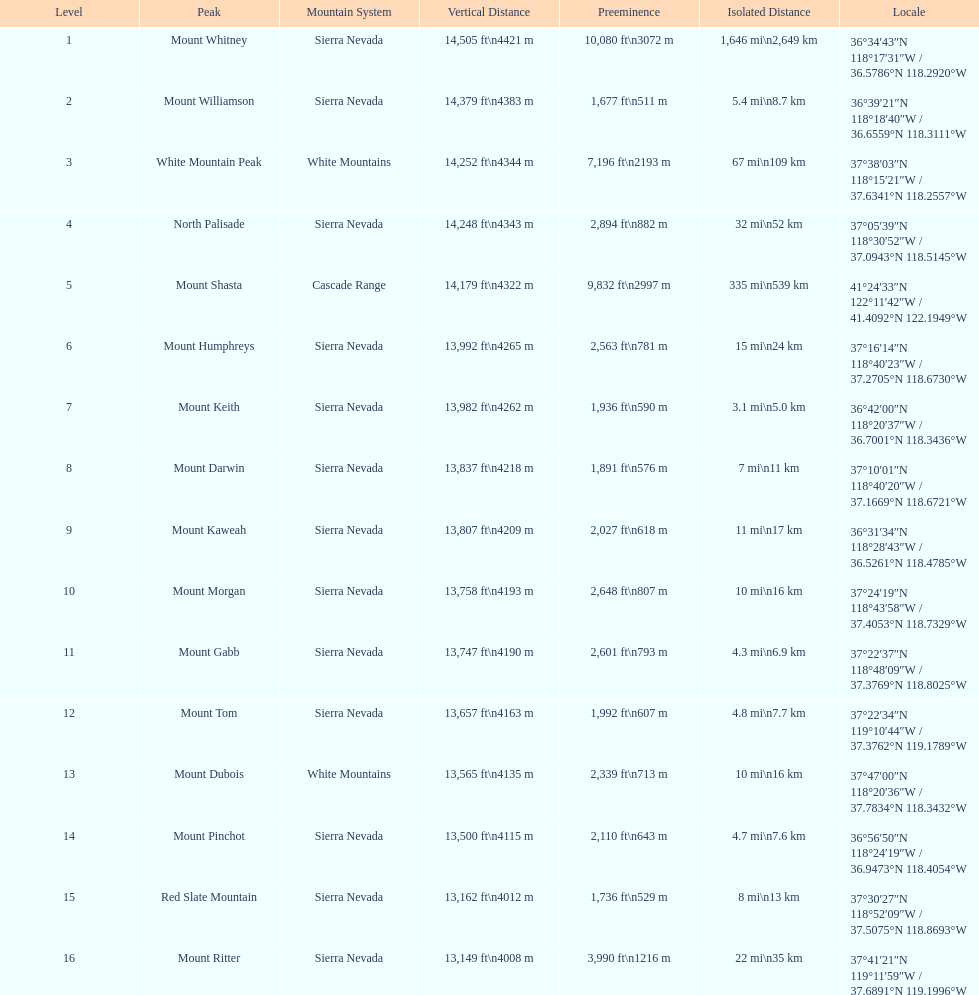Which is higher, mount humphreys or mount kaweah? Mount Humphreys. 